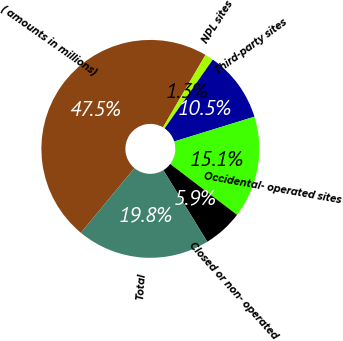Convert chart to OTSL. <chart><loc_0><loc_0><loc_500><loc_500><pie_chart><fcel>( amounts in millions)<fcel>NPL sites<fcel>Third-party sites<fcel>Occidental- operated sites<fcel>Closed or non- operated<fcel>Total<nl><fcel>47.45%<fcel>1.27%<fcel>10.51%<fcel>15.13%<fcel>5.89%<fcel>19.75%<nl></chart> 